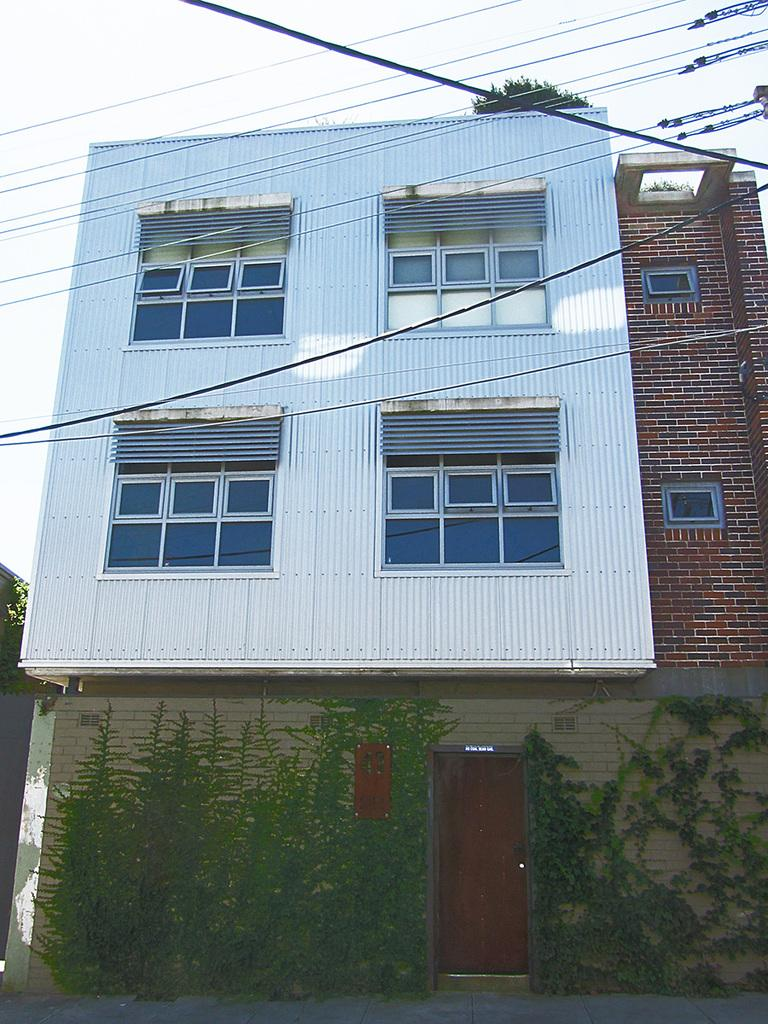What type of structure is present in the image? There is a building in the image. What natural elements can be seen in the image? There are trees in the image. What man-made elements are visible in the image? Cables are visible in the image. What can be seen in the background of the image? The sky is visible in the background of the image. How many clovers are growing on the building in the image? There are no clovers visible on the building in the image. What type of glue is being used to attach the cables to the trees in the image? There is no glue or attachment method visible for the cables in the image. 